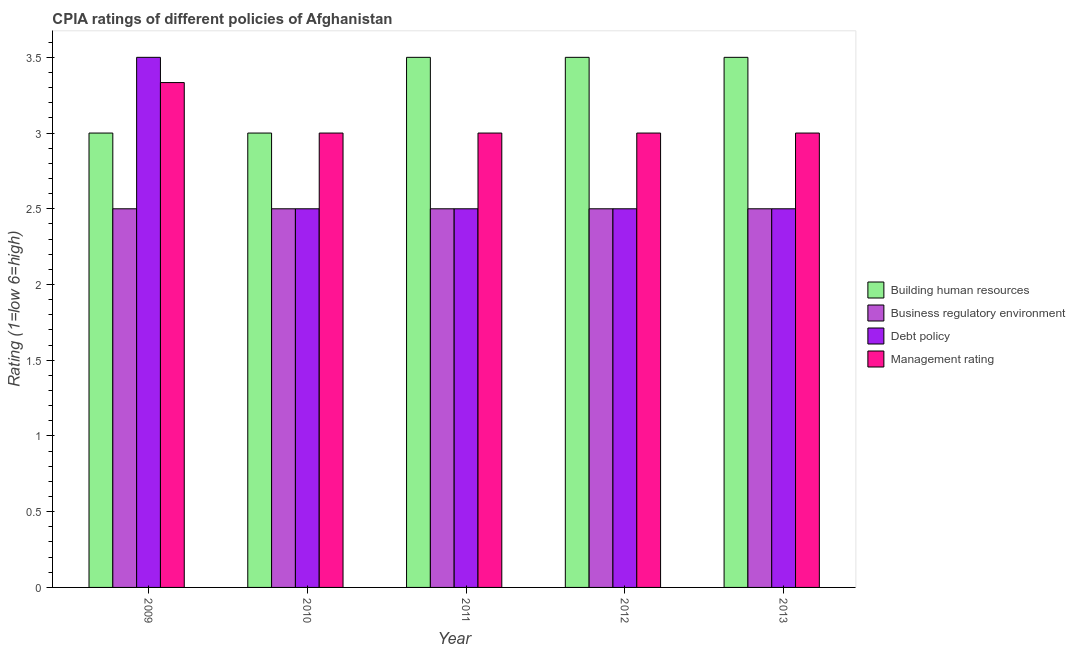How many bars are there on the 3rd tick from the left?
Your answer should be compact. 4. Across all years, what is the minimum cpia rating of management?
Offer a terse response. 3. What is the difference between the cpia rating of management in 2012 and the cpia rating of building human resources in 2013?
Your response must be concise. 0. In the year 2013, what is the difference between the cpia rating of debt policy and cpia rating of business regulatory environment?
Provide a succinct answer. 0. What is the ratio of the cpia rating of building human resources in 2010 to that in 2011?
Give a very brief answer. 0.86. Is the sum of the cpia rating of business regulatory environment in 2011 and 2013 greater than the maximum cpia rating of debt policy across all years?
Your response must be concise. Yes. What does the 3rd bar from the left in 2013 represents?
Give a very brief answer. Debt policy. What does the 1st bar from the right in 2012 represents?
Your answer should be very brief. Management rating. Is it the case that in every year, the sum of the cpia rating of building human resources and cpia rating of business regulatory environment is greater than the cpia rating of debt policy?
Give a very brief answer. Yes. How many years are there in the graph?
Keep it short and to the point. 5. What is the difference between two consecutive major ticks on the Y-axis?
Give a very brief answer. 0.5. Does the graph contain any zero values?
Your answer should be compact. No. Where does the legend appear in the graph?
Offer a very short reply. Center right. How many legend labels are there?
Your response must be concise. 4. What is the title of the graph?
Give a very brief answer. CPIA ratings of different policies of Afghanistan. What is the label or title of the X-axis?
Your answer should be very brief. Year. What is the Rating (1=low 6=high) in Business regulatory environment in 2009?
Your answer should be compact. 2.5. What is the Rating (1=low 6=high) of Management rating in 2009?
Provide a short and direct response. 3.33. What is the Rating (1=low 6=high) of Debt policy in 2010?
Your answer should be very brief. 2.5. What is the Rating (1=low 6=high) of Building human resources in 2011?
Your answer should be compact. 3.5. What is the Rating (1=low 6=high) of Business regulatory environment in 2011?
Provide a succinct answer. 2.5. What is the Rating (1=low 6=high) in Management rating in 2011?
Your answer should be very brief. 3. What is the Rating (1=low 6=high) in Business regulatory environment in 2012?
Your answer should be very brief. 2.5. What is the Rating (1=low 6=high) in Debt policy in 2012?
Your answer should be compact. 2.5. What is the Rating (1=low 6=high) in Management rating in 2012?
Offer a terse response. 3. What is the Rating (1=low 6=high) in Business regulatory environment in 2013?
Offer a very short reply. 2.5. What is the Rating (1=low 6=high) in Debt policy in 2013?
Give a very brief answer. 2.5. What is the Rating (1=low 6=high) of Management rating in 2013?
Your response must be concise. 3. Across all years, what is the maximum Rating (1=low 6=high) of Business regulatory environment?
Your response must be concise. 2.5. Across all years, what is the maximum Rating (1=low 6=high) of Management rating?
Provide a short and direct response. 3.33. Across all years, what is the minimum Rating (1=low 6=high) of Business regulatory environment?
Make the answer very short. 2.5. Across all years, what is the minimum Rating (1=low 6=high) in Debt policy?
Your answer should be compact. 2.5. What is the total Rating (1=low 6=high) in Management rating in the graph?
Give a very brief answer. 15.33. What is the difference between the Rating (1=low 6=high) of Business regulatory environment in 2009 and that in 2010?
Keep it short and to the point. 0. What is the difference between the Rating (1=low 6=high) of Debt policy in 2009 and that in 2010?
Provide a short and direct response. 1. What is the difference between the Rating (1=low 6=high) of Management rating in 2009 and that in 2010?
Provide a succinct answer. 0.33. What is the difference between the Rating (1=low 6=high) of Debt policy in 2009 and that in 2011?
Ensure brevity in your answer.  1. What is the difference between the Rating (1=low 6=high) in Business regulatory environment in 2009 and that in 2012?
Your answer should be compact. 0. What is the difference between the Rating (1=low 6=high) of Debt policy in 2009 and that in 2012?
Provide a short and direct response. 1. What is the difference between the Rating (1=low 6=high) of Business regulatory environment in 2009 and that in 2013?
Provide a succinct answer. 0. What is the difference between the Rating (1=low 6=high) in Building human resources in 2010 and that in 2011?
Offer a very short reply. -0.5. What is the difference between the Rating (1=low 6=high) in Business regulatory environment in 2010 and that in 2013?
Offer a terse response. 0. What is the difference between the Rating (1=low 6=high) of Management rating in 2010 and that in 2013?
Provide a succinct answer. 0. What is the difference between the Rating (1=low 6=high) in Debt policy in 2011 and that in 2012?
Keep it short and to the point. 0. What is the difference between the Rating (1=low 6=high) in Management rating in 2011 and that in 2013?
Your answer should be very brief. 0. What is the difference between the Rating (1=low 6=high) of Business regulatory environment in 2012 and that in 2013?
Make the answer very short. 0. What is the difference between the Rating (1=low 6=high) in Debt policy in 2012 and that in 2013?
Give a very brief answer. 0. What is the difference between the Rating (1=low 6=high) in Management rating in 2012 and that in 2013?
Keep it short and to the point. 0. What is the difference between the Rating (1=low 6=high) in Building human resources in 2009 and the Rating (1=low 6=high) in Debt policy in 2010?
Provide a short and direct response. 0.5. What is the difference between the Rating (1=low 6=high) in Building human resources in 2009 and the Rating (1=low 6=high) in Management rating in 2010?
Your answer should be very brief. 0. What is the difference between the Rating (1=low 6=high) in Building human resources in 2009 and the Rating (1=low 6=high) in Debt policy in 2011?
Your answer should be compact. 0.5. What is the difference between the Rating (1=low 6=high) of Business regulatory environment in 2009 and the Rating (1=low 6=high) of Debt policy in 2011?
Your answer should be very brief. 0. What is the difference between the Rating (1=low 6=high) in Debt policy in 2009 and the Rating (1=low 6=high) in Management rating in 2011?
Provide a succinct answer. 0.5. What is the difference between the Rating (1=low 6=high) in Building human resources in 2009 and the Rating (1=low 6=high) in Business regulatory environment in 2012?
Provide a short and direct response. 0.5. What is the difference between the Rating (1=low 6=high) in Building human resources in 2009 and the Rating (1=low 6=high) in Debt policy in 2012?
Make the answer very short. 0.5. What is the difference between the Rating (1=low 6=high) in Business regulatory environment in 2009 and the Rating (1=low 6=high) in Management rating in 2012?
Give a very brief answer. -0.5. What is the difference between the Rating (1=low 6=high) of Debt policy in 2009 and the Rating (1=low 6=high) of Management rating in 2012?
Ensure brevity in your answer.  0.5. What is the difference between the Rating (1=low 6=high) of Building human resources in 2009 and the Rating (1=low 6=high) of Debt policy in 2013?
Provide a short and direct response. 0.5. What is the difference between the Rating (1=low 6=high) in Building human resources in 2009 and the Rating (1=low 6=high) in Management rating in 2013?
Make the answer very short. 0. What is the difference between the Rating (1=low 6=high) of Business regulatory environment in 2009 and the Rating (1=low 6=high) of Management rating in 2013?
Keep it short and to the point. -0.5. What is the difference between the Rating (1=low 6=high) of Building human resources in 2010 and the Rating (1=low 6=high) of Business regulatory environment in 2011?
Your response must be concise. 0.5. What is the difference between the Rating (1=low 6=high) of Business regulatory environment in 2010 and the Rating (1=low 6=high) of Management rating in 2011?
Give a very brief answer. -0.5. What is the difference between the Rating (1=low 6=high) of Debt policy in 2010 and the Rating (1=low 6=high) of Management rating in 2011?
Ensure brevity in your answer.  -0.5. What is the difference between the Rating (1=low 6=high) in Building human resources in 2010 and the Rating (1=low 6=high) in Management rating in 2012?
Your answer should be compact. 0. What is the difference between the Rating (1=low 6=high) of Business regulatory environment in 2010 and the Rating (1=low 6=high) of Management rating in 2012?
Provide a succinct answer. -0.5. What is the difference between the Rating (1=low 6=high) of Building human resources in 2010 and the Rating (1=low 6=high) of Management rating in 2013?
Provide a short and direct response. 0. What is the difference between the Rating (1=low 6=high) of Business regulatory environment in 2010 and the Rating (1=low 6=high) of Debt policy in 2013?
Your answer should be very brief. 0. What is the difference between the Rating (1=low 6=high) in Building human resources in 2011 and the Rating (1=low 6=high) in Debt policy in 2012?
Your response must be concise. 1. What is the difference between the Rating (1=low 6=high) in Business regulatory environment in 2011 and the Rating (1=low 6=high) in Debt policy in 2012?
Your answer should be compact. 0. What is the difference between the Rating (1=low 6=high) of Building human resources in 2011 and the Rating (1=low 6=high) of Business regulatory environment in 2013?
Ensure brevity in your answer.  1. What is the difference between the Rating (1=low 6=high) of Building human resources in 2011 and the Rating (1=low 6=high) of Debt policy in 2013?
Offer a very short reply. 1. What is the difference between the Rating (1=low 6=high) of Building human resources in 2011 and the Rating (1=low 6=high) of Management rating in 2013?
Your answer should be compact. 0.5. What is the difference between the Rating (1=low 6=high) in Business regulatory environment in 2011 and the Rating (1=low 6=high) in Debt policy in 2013?
Your answer should be compact. 0. What is the difference between the Rating (1=low 6=high) in Business regulatory environment in 2011 and the Rating (1=low 6=high) in Management rating in 2013?
Your answer should be compact. -0.5. What is the difference between the Rating (1=low 6=high) in Debt policy in 2011 and the Rating (1=low 6=high) in Management rating in 2013?
Provide a short and direct response. -0.5. What is the difference between the Rating (1=low 6=high) in Building human resources in 2012 and the Rating (1=low 6=high) in Business regulatory environment in 2013?
Offer a terse response. 1. What is the difference between the Rating (1=low 6=high) in Building human resources in 2012 and the Rating (1=low 6=high) in Debt policy in 2013?
Your answer should be very brief. 1. What is the difference between the Rating (1=low 6=high) of Building human resources in 2012 and the Rating (1=low 6=high) of Management rating in 2013?
Make the answer very short. 0.5. What is the difference between the Rating (1=low 6=high) of Business regulatory environment in 2012 and the Rating (1=low 6=high) of Debt policy in 2013?
Your response must be concise. 0. What is the difference between the Rating (1=low 6=high) in Debt policy in 2012 and the Rating (1=low 6=high) in Management rating in 2013?
Keep it short and to the point. -0.5. What is the average Rating (1=low 6=high) of Debt policy per year?
Make the answer very short. 2.7. What is the average Rating (1=low 6=high) of Management rating per year?
Make the answer very short. 3.07. In the year 2009, what is the difference between the Rating (1=low 6=high) of Building human resources and Rating (1=low 6=high) of Business regulatory environment?
Provide a succinct answer. 0.5. In the year 2009, what is the difference between the Rating (1=low 6=high) of Building human resources and Rating (1=low 6=high) of Debt policy?
Offer a terse response. -0.5. In the year 2009, what is the difference between the Rating (1=low 6=high) in Debt policy and Rating (1=low 6=high) in Management rating?
Provide a succinct answer. 0.17. In the year 2010, what is the difference between the Rating (1=low 6=high) in Business regulatory environment and Rating (1=low 6=high) in Debt policy?
Make the answer very short. 0. In the year 2010, what is the difference between the Rating (1=low 6=high) in Business regulatory environment and Rating (1=low 6=high) in Management rating?
Give a very brief answer. -0.5. In the year 2010, what is the difference between the Rating (1=low 6=high) in Debt policy and Rating (1=low 6=high) in Management rating?
Offer a very short reply. -0.5. In the year 2011, what is the difference between the Rating (1=low 6=high) in Building human resources and Rating (1=low 6=high) in Debt policy?
Keep it short and to the point. 1. In the year 2012, what is the difference between the Rating (1=low 6=high) of Building human resources and Rating (1=low 6=high) of Business regulatory environment?
Make the answer very short. 1. In the year 2012, what is the difference between the Rating (1=low 6=high) in Building human resources and Rating (1=low 6=high) in Debt policy?
Offer a terse response. 1. In the year 2012, what is the difference between the Rating (1=low 6=high) of Building human resources and Rating (1=low 6=high) of Management rating?
Give a very brief answer. 0.5. In the year 2012, what is the difference between the Rating (1=low 6=high) of Business regulatory environment and Rating (1=low 6=high) of Management rating?
Your answer should be compact. -0.5. In the year 2013, what is the difference between the Rating (1=low 6=high) in Building human resources and Rating (1=low 6=high) in Business regulatory environment?
Your response must be concise. 1. In the year 2013, what is the difference between the Rating (1=low 6=high) of Building human resources and Rating (1=low 6=high) of Debt policy?
Give a very brief answer. 1. In the year 2013, what is the difference between the Rating (1=low 6=high) in Building human resources and Rating (1=low 6=high) in Management rating?
Your answer should be compact. 0.5. In the year 2013, what is the difference between the Rating (1=low 6=high) in Business regulatory environment and Rating (1=low 6=high) in Management rating?
Your answer should be compact. -0.5. In the year 2013, what is the difference between the Rating (1=low 6=high) in Debt policy and Rating (1=low 6=high) in Management rating?
Ensure brevity in your answer.  -0.5. What is the ratio of the Rating (1=low 6=high) of Building human resources in 2009 to that in 2010?
Your response must be concise. 1. What is the ratio of the Rating (1=low 6=high) of Management rating in 2009 to that in 2010?
Offer a very short reply. 1.11. What is the ratio of the Rating (1=low 6=high) of Management rating in 2009 to that in 2011?
Keep it short and to the point. 1.11. What is the ratio of the Rating (1=low 6=high) of Building human resources in 2009 to that in 2012?
Offer a very short reply. 0.86. What is the ratio of the Rating (1=low 6=high) in Management rating in 2009 to that in 2012?
Your answer should be very brief. 1.11. What is the ratio of the Rating (1=low 6=high) in Building human resources in 2009 to that in 2013?
Your answer should be very brief. 0.86. What is the ratio of the Rating (1=low 6=high) of Business regulatory environment in 2009 to that in 2013?
Ensure brevity in your answer.  1. What is the ratio of the Rating (1=low 6=high) in Debt policy in 2009 to that in 2013?
Keep it short and to the point. 1.4. What is the ratio of the Rating (1=low 6=high) of Management rating in 2009 to that in 2013?
Offer a terse response. 1.11. What is the ratio of the Rating (1=low 6=high) in Building human resources in 2010 to that in 2011?
Offer a very short reply. 0.86. What is the ratio of the Rating (1=low 6=high) in Business regulatory environment in 2010 to that in 2012?
Offer a terse response. 1. What is the ratio of the Rating (1=low 6=high) in Management rating in 2010 to that in 2012?
Your response must be concise. 1. What is the ratio of the Rating (1=low 6=high) of Building human resources in 2010 to that in 2013?
Provide a succinct answer. 0.86. What is the ratio of the Rating (1=low 6=high) of Management rating in 2010 to that in 2013?
Ensure brevity in your answer.  1. What is the ratio of the Rating (1=low 6=high) in Management rating in 2011 to that in 2012?
Your response must be concise. 1. What is the ratio of the Rating (1=low 6=high) of Building human resources in 2011 to that in 2013?
Your answer should be compact. 1. What is the ratio of the Rating (1=low 6=high) in Business regulatory environment in 2011 to that in 2013?
Your answer should be very brief. 1. What is the ratio of the Rating (1=low 6=high) in Management rating in 2011 to that in 2013?
Provide a succinct answer. 1. What is the ratio of the Rating (1=low 6=high) of Business regulatory environment in 2012 to that in 2013?
Provide a succinct answer. 1. What is the ratio of the Rating (1=low 6=high) in Management rating in 2012 to that in 2013?
Your response must be concise. 1. What is the difference between the highest and the lowest Rating (1=low 6=high) in Debt policy?
Your response must be concise. 1. What is the difference between the highest and the lowest Rating (1=low 6=high) in Management rating?
Provide a short and direct response. 0.33. 